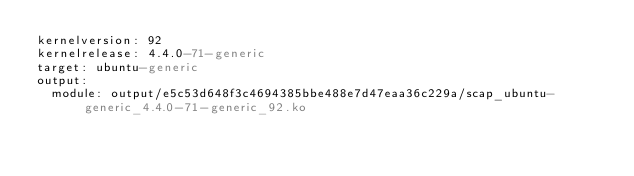Convert code to text. <code><loc_0><loc_0><loc_500><loc_500><_YAML_>kernelversion: 92
kernelrelease: 4.4.0-71-generic
target: ubuntu-generic
output:
  module: output/e5c53d648f3c4694385bbe488e7d47eaa36c229a/scap_ubuntu-generic_4.4.0-71-generic_92.ko
</code> 